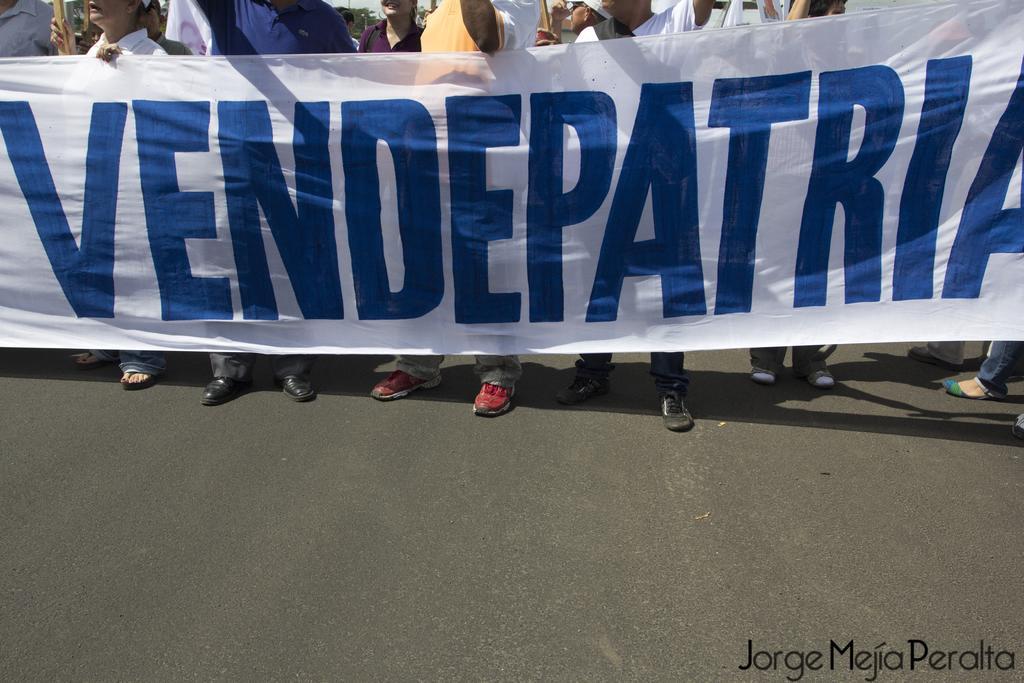Can you describe this image briefly? In this picture we can see a group of men standing on the road and holding the white cloth banner in the hand. 